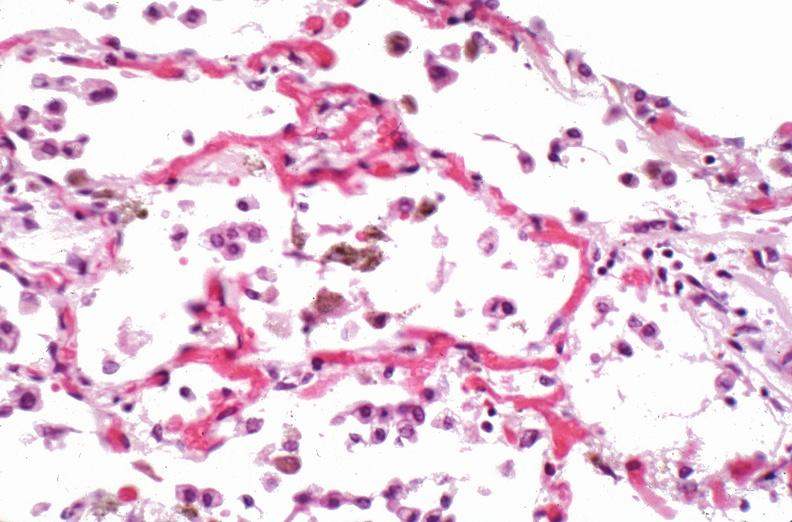what does this image show?
Answer the question using a single word or phrase. Lung 